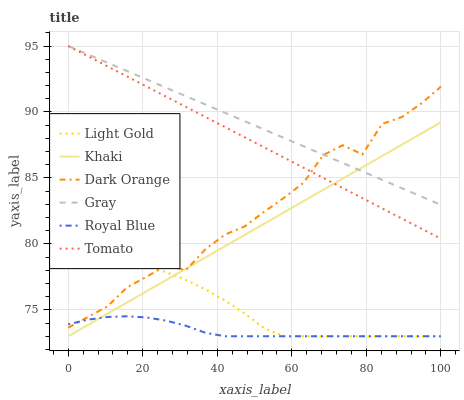Does Royal Blue have the minimum area under the curve?
Answer yes or no. Yes. Does Gray have the maximum area under the curve?
Answer yes or no. Yes. Does Dark Orange have the minimum area under the curve?
Answer yes or no. No. Does Dark Orange have the maximum area under the curve?
Answer yes or no. No. Is Tomato the smoothest?
Answer yes or no. Yes. Is Dark Orange the roughest?
Answer yes or no. Yes. Is Khaki the smoothest?
Answer yes or no. No. Is Khaki the roughest?
Answer yes or no. No. Does Khaki have the lowest value?
Answer yes or no. Yes. Does Dark Orange have the lowest value?
Answer yes or no. No. Does Gray have the highest value?
Answer yes or no. Yes. Does Dark Orange have the highest value?
Answer yes or no. No. Is Royal Blue less than Tomato?
Answer yes or no. Yes. Is Gray greater than Light Gold?
Answer yes or no. Yes. Does Light Gold intersect Dark Orange?
Answer yes or no. Yes. Is Light Gold less than Dark Orange?
Answer yes or no. No. Is Light Gold greater than Dark Orange?
Answer yes or no. No. Does Royal Blue intersect Tomato?
Answer yes or no. No. 